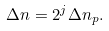<formula> <loc_0><loc_0><loc_500><loc_500>\Delta n = 2 ^ { j } \Delta n _ { p } .</formula> 